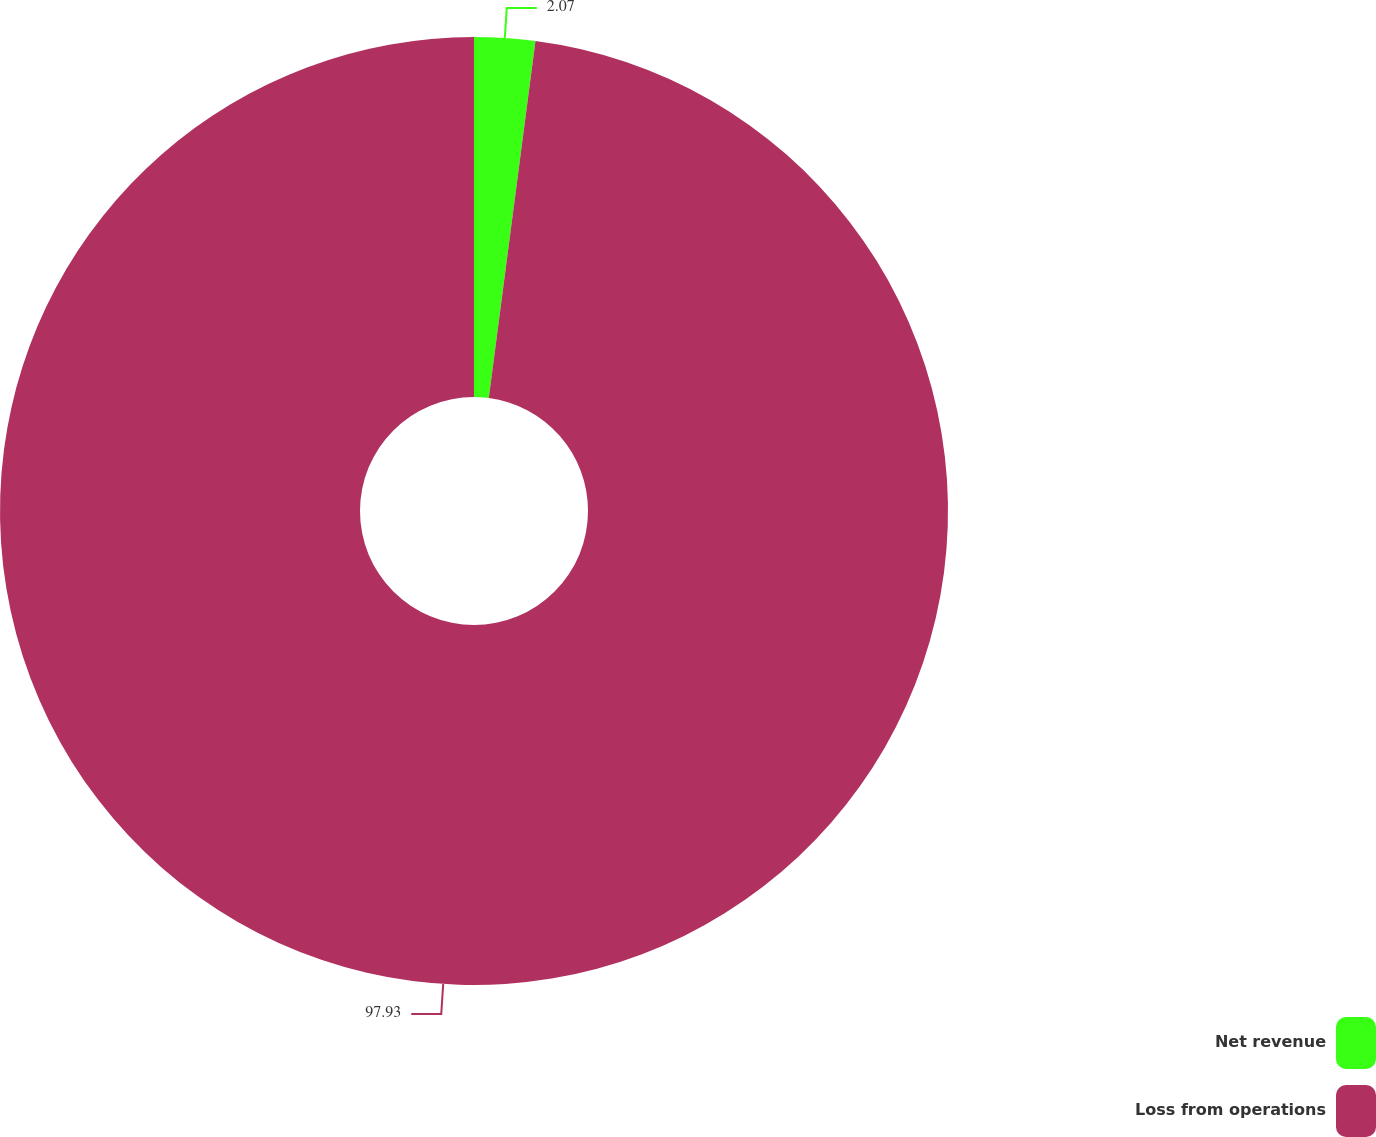<chart> <loc_0><loc_0><loc_500><loc_500><pie_chart><fcel>Net revenue<fcel>Loss from operations<nl><fcel>2.07%<fcel>97.93%<nl></chart> 